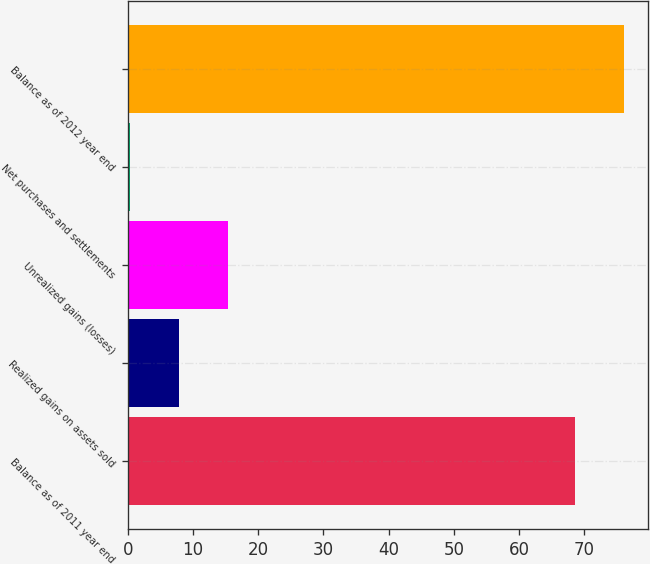Convert chart to OTSL. <chart><loc_0><loc_0><loc_500><loc_500><bar_chart><fcel>Balance as of 2011 year end<fcel>Realized gains on assets sold<fcel>Unrealized gains (losses)<fcel>Net purchases and settlements<fcel>Balance as of 2012 year end<nl><fcel>68.6<fcel>7.86<fcel>15.32<fcel>0.4<fcel>76.06<nl></chart> 